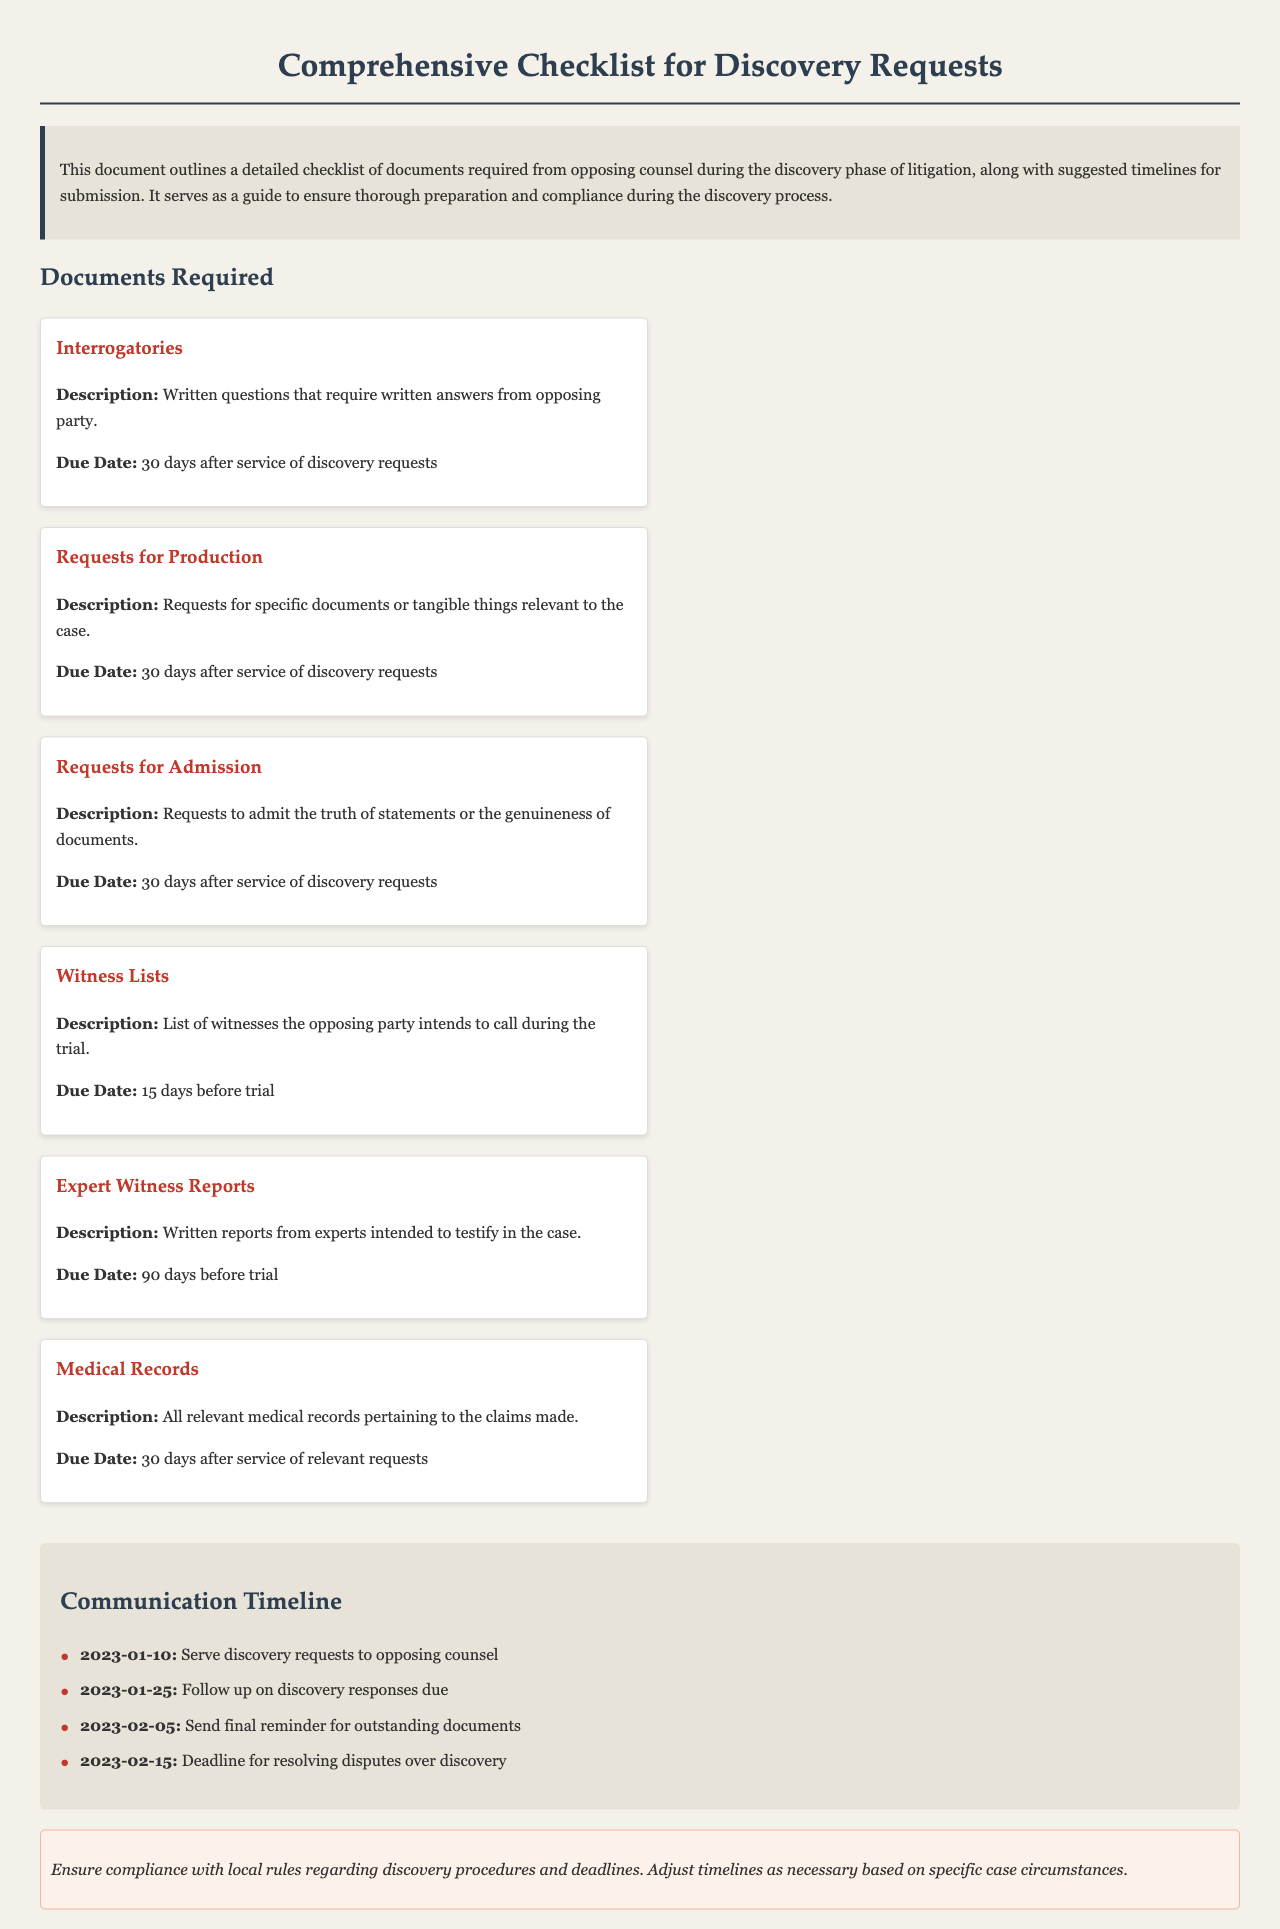what is the due date for Interrogatories? The due date is specifically mentioned as 30 days after the service of discovery requests.
Answer: 30 days after service of discovery requests what type of documents must be submitted 90 days before trial? The document specifies that Expert Witness Reports are due 90 days before trial.
Answer: Expert Witness Reports how many days before trial are Witness Lists due? The document states that Witness Lists are due 15 days before trial.
Answer: 15 days before trial what is the purpose of Requests for Admission? The document outlines that Requests for Admission are for admitting the truth of statements or the genuineness of documents.
Answer: To admit the truth of statements or the genuineness of documents when should you follow up on discovery responses? The document gives a specific date for following up on discovery responses as 2023-01-25.
Answer: 2023-01-25 how long do you have to submit Medical Records? Medical Records must be submitted 30 days after the service of relevant requests, as stated in the document.
Answer: 30 days after service of relevant requests what is the first action in the communication timeline? The first action mentioned in the timeline is serving discovery requests to opposing counsel.
Answer: Serve discovery requests to opposing counsel what kind of documents are included under Requests for Production? The document describes Requests for Production as requests for specific documents or tangible things relevant to the case.
Answer: Specific documents or tangible things relevant to the case what reminder is to be sent on 2023-02-05? The document specifies sending a final reminder for outstanding documents on that date.
Answer: Send final reminder for outstanding documents 